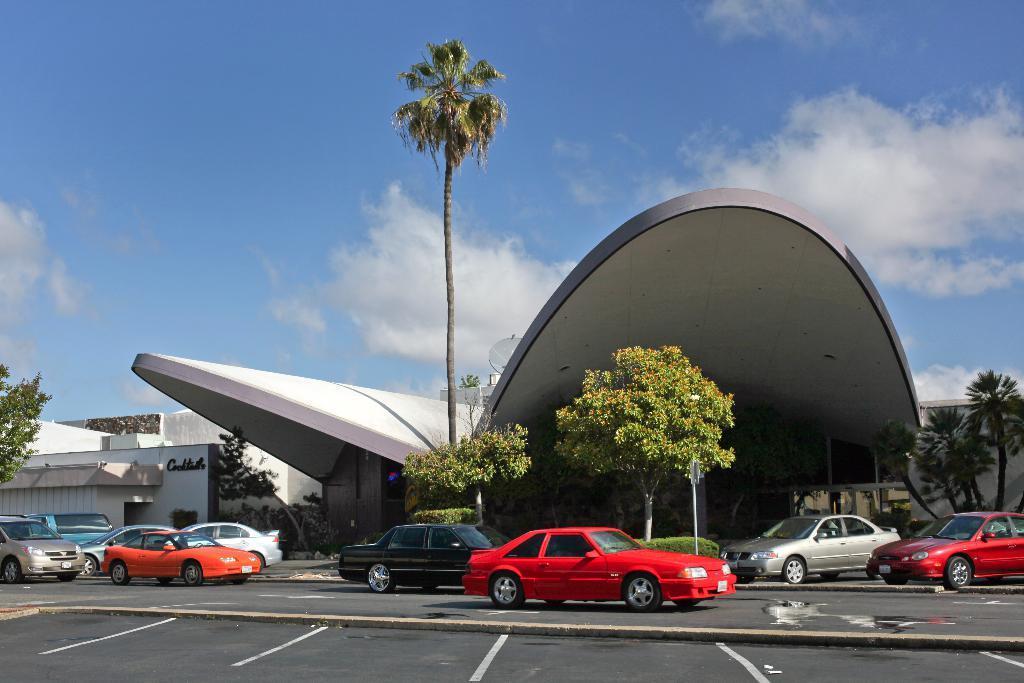In one or two sentences, can you explain what this image depicts? In the foreground of this image, on the bottom, there is the road and few objects are moving on the road. In the background, there is a building, few trees, sky and the cloud. 